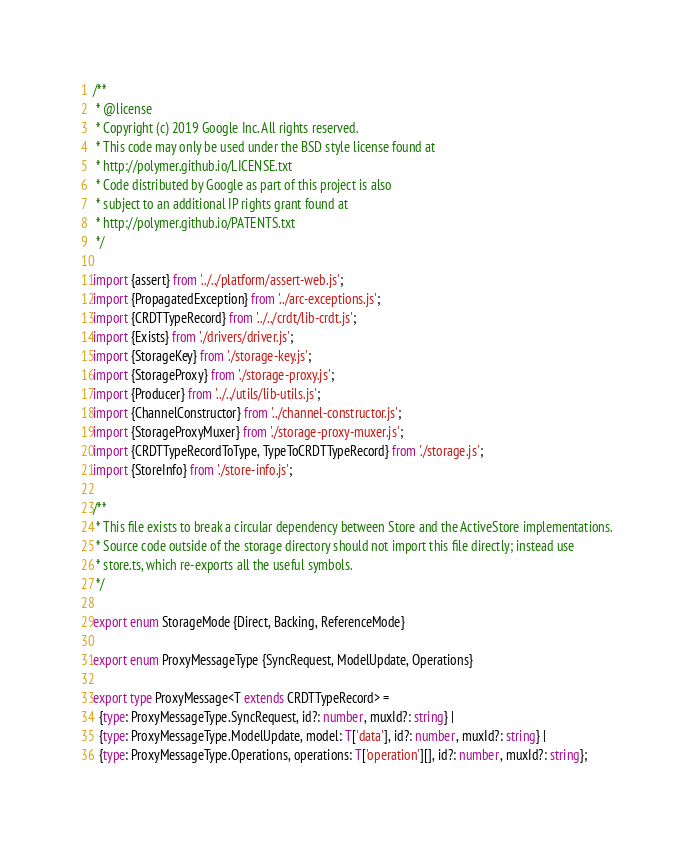Convert code to text. <code><loc_0><loc_0><loc_500><loc_500><_TypeScript_>/**
 * @license
 * Copyright (c) 2019 Google Inc. All rights reserved.
 * This code may only be used under the BSD style license found at
 * http://polymer.github.io/LICENSE.txt
 * Code distributed by Google as part of this project is also
 * subject to an additional IP rights grant found at
 * http://polymer.github.io/PATENTS.txt
 */

import {assert} from '../../platform/assert-web.js';
import {PropagatedException} from '../arc-exceptions.js';
import {CRDTTypeRecord} from '../../crdt/lib-crdt.js';
import {Exists} from './drivers/driver.js';
import {StorageKey} from './storage-key.js';
import {StorageProxy} from './storage-proxy.js';
import {Producer} from '../../utils/lib-utils.js';
import {ChannelConstructor} from '../channel-constructor.js';
import {StorageProxyMuxer} from './storage-proxy-muxer.js';
import {CRDTTypeRecordToType, TypeToCRDTTypeRecord} from './storage.js';
import {StoreInfo} from './store-info.js';

/**
 * This file exists to break a circular dependency between Store and the ActiveStore implementations.
 * Source code outside of the storage directory should not import this file directly; instead use
 * store.ts, which re-exports all the useful symbols.
 */

export enum StorageMode {Direct, Backing, ReferenceMode}

export enum ProxyMessageType {SyncRequest, ModelUpdate, Operations}

export type ProxyMessage<T extends CRDTTypeRecord> =
  {type: ProxyMessageType.SyncRequest, id?: number, muxId?: string} |
  {type: ProxyMessageType.ModelUpdate, model: T['data'], id?: number, muxId?: string} |
  {type: ProxyMessageType.Operations, operations: T['operation'][], id?: number, muxId?: string};
</code> 